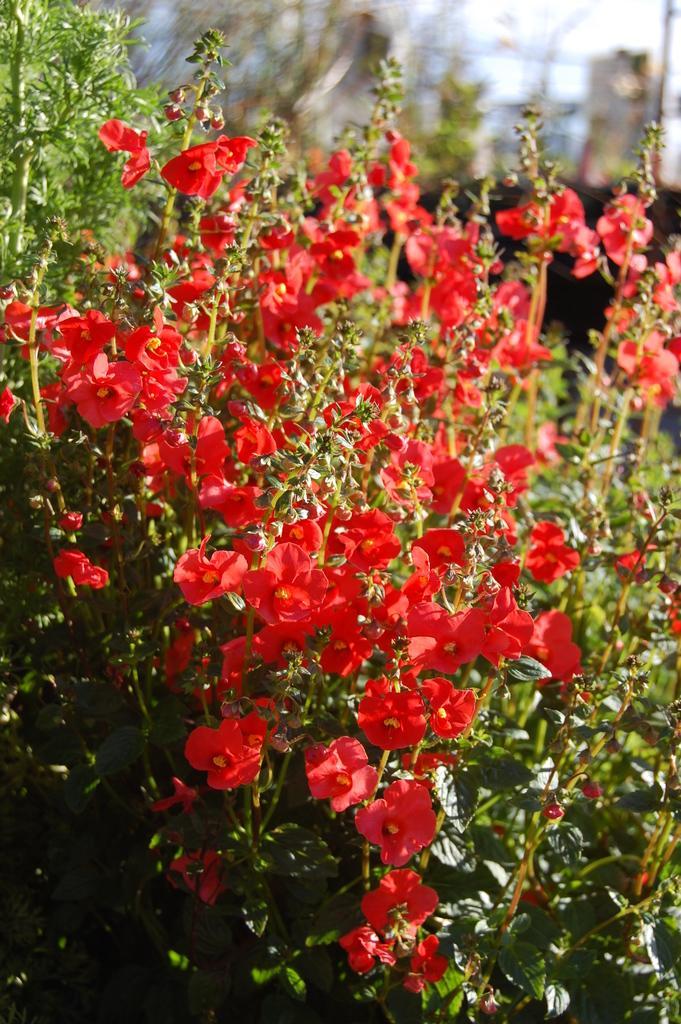Please provide a concise description of this image. In this image I can see number of red colour flowers in the front. On the top right side I can see a pole and I can see this image is little bit blurry in the background. 